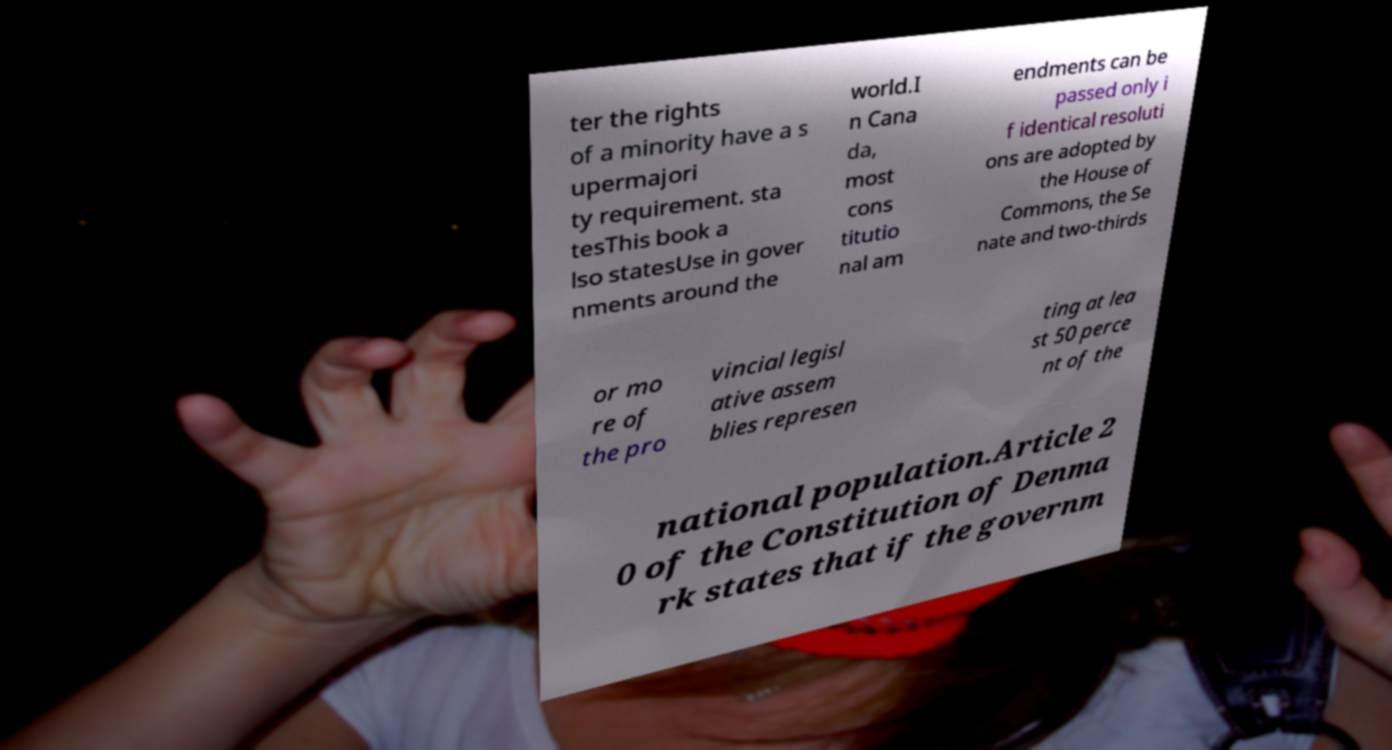Could you assist in decoding the text presented in this image and type it out clearly? ter the rights of a minority have a s upermajori ty requirement. sta tesThis book a lso statesUse in gover nments around the world.I n Cana da, most cons titutio nal am endments can be passed only i f identical resoluti ons are adopted by the House of Commons, the Se nate and two-thirds or mo re of the pro vincial legisl ative assem blies represen ting at lea st 50 perce nt of the national population.Article 2 0 of the Constitution of Denma rk states that if the governm 